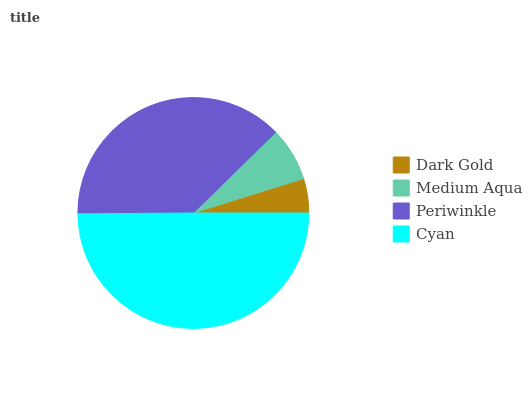Is Dark Gold the minimum?
Answer yes or no. Yes. Is Cyan the maximum?
Answer yes or no. Yes. Is Medium Aqua the minimum?
Answer yes or no. No. Is Medium Aqua the maximum?
Answer yes or no. No. Is Medium Aqua greater than Dark Gold?
Answer yes or no. Yes. Is Dark Gold less than Medium Aqua?
Answer yes or no. Yes. Is Dark Gold greater than Medium Aqua?
Answer yes or no. No. Is Medium Aqua less than Dark Gold?
Answer yes or no. No. Is Periwinkle the high median?
Answer yes or no. Yes. Is Medium Aqua the low median?
Answer yes or no. Yes. Is Medium Aqua the high median?
Answer yes or no. No. Is Cyan the low median?
Answer yes or no. No. 